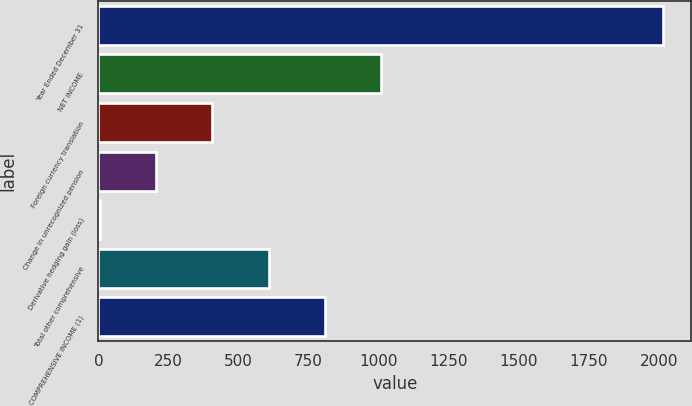<chart> <loc_0><loc_0><loc_500><loc_500><bar_chart><fcel>Year Ended December 31<fcel>NET INCOME<fcel>Foreign currency translation<fcel>Change in unrecognized pension<fcel>Derivative hedging gain (loss)<fcel>Total other comprehensive<fcel>COMPREHENSIVE INCOME (1)<nl><fcel>2014<fcel>1009.75<fcel>407.2<fcel>206.35<fcel>5.5<fcel>608.05<fcel>808.9<nl></chart> 